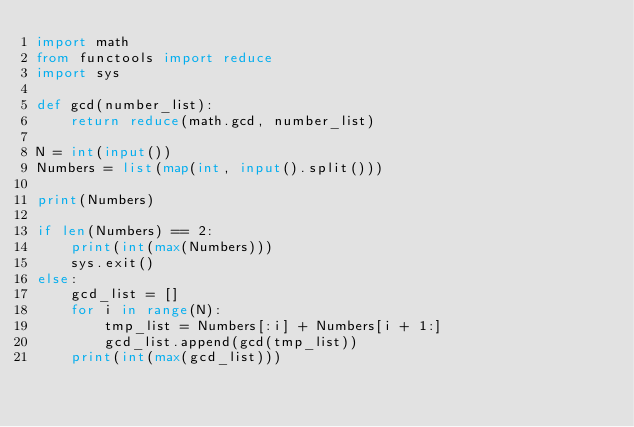<code> <loc_0><loc_0><loc_500><loc_500><_Python_>import math
from functools import reduce
import sys

def gcd(number_list):
    return reduce(math.gcd, number_list)

N = int(input())
Numbers = list(map(int, input().split()))

print(Numbers)

if len(Numbers) == 2:
    print(int(max(Numbers)))
    sys.exit()
else:
    gcd_list = []
    for i in range(N):
        tmp_list = Numbers[:i] + Numbers[i + 1:]
        gcd_list.append(gcd(tmp_list))
    print(int(max(gcd_list)))
</code> 